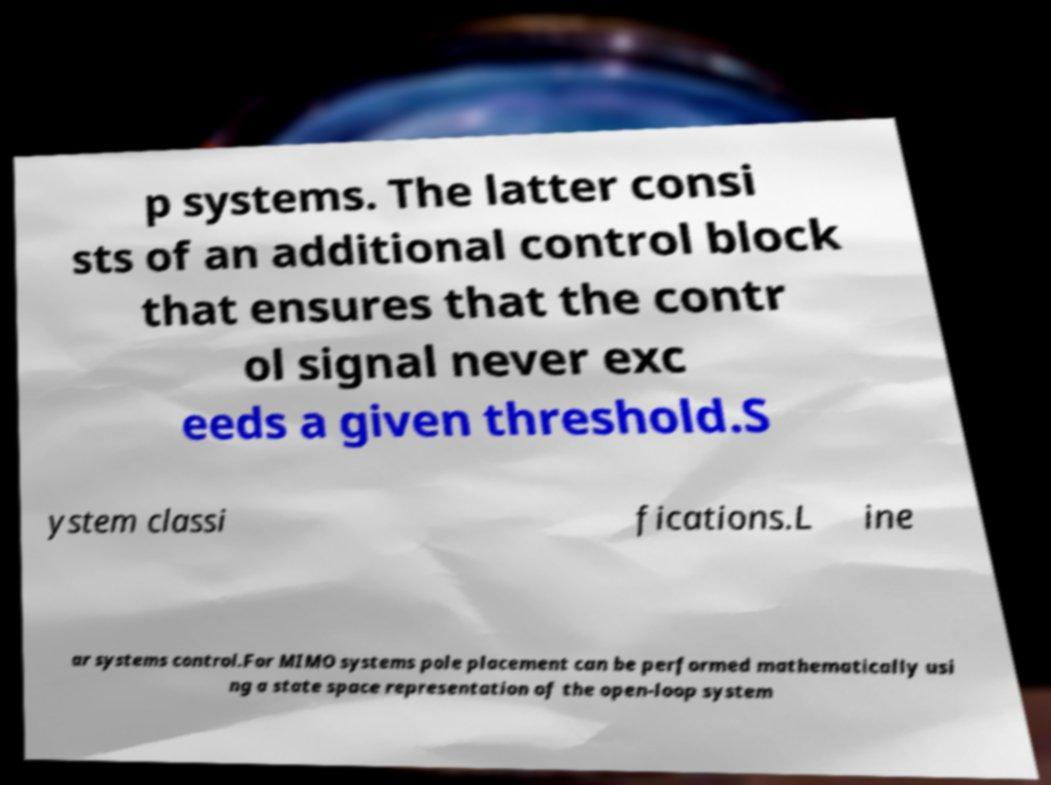Please read and relay the text visible in this image. What does it say? p systems. The latter consi sts of an additional control block that ensures that the contr ol signal never exc eeds a given threshold.S ystem classi fications.L ine ar systems control.For MIMO systems pole placement can be performed mathematically usi ng a state space representation of the open-loop system 